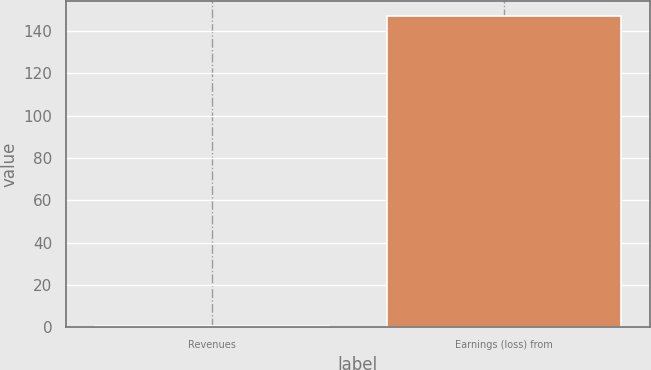Convert chart. <chart><loc_0><loc_0><loc_500><loc_500><bar_chart><fcel>Revenues<fcel>Earnings (loss) from<nl><fcel>0.5<fcel>146.8<nl></chart> 